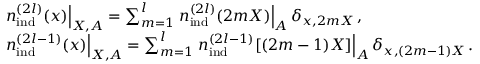Convert formula to latex. <formula><loc_0><loc_0><loc_500><loc_500>\begin{array} { r l } & { { n } _ { i n d } ^ { ( 2 l ) } ( x ) \right | _ { X , A } = \sum _ { m = 1 } ^ { l } { n } _ { i n d } ^ { ( 2 l ) } ( 2 m X ) \right | _ { A } \delta _ { x , 2 m X } \, , } \\ & { { n } _ { i n d } ^ { ( 2 l - 1 ) } ( x ) \right | _ { X , A } = \sum _ { m = 1 } ^ { l } { n } _ { i n d } ^ { ( 2 l - 1 ) } [ ( 2 m - 1 ) X ] \right | _ { A } \delta _ { x , ( 2 m - 1 ) X } \, . } \end{array}</formula> 